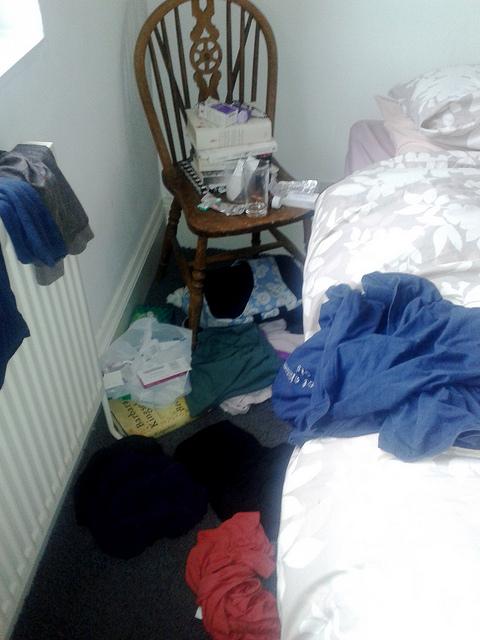What color is the bedspread?
Answer briefly. White. Did someone trash the room?
Give a very brief answer. Yes. What color is the chair?
Give a very brief answer. Brown. 